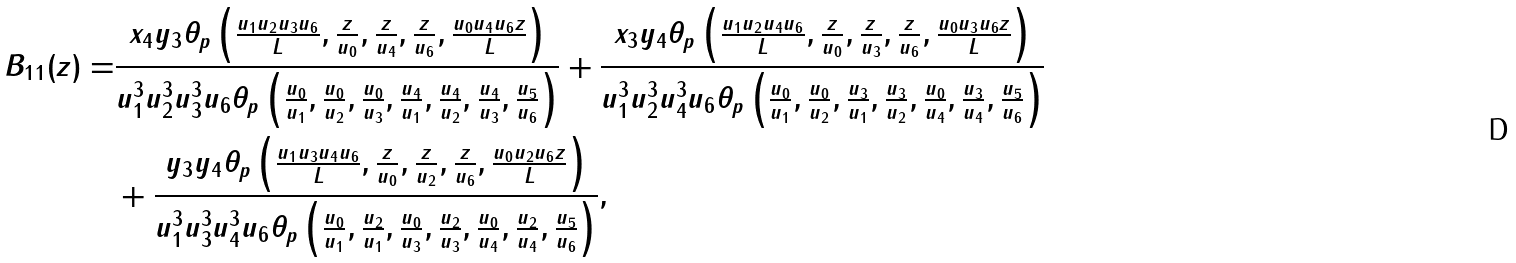Convert formula to latex. <formula><loc_0><loc_0><loc_500><loc_500>B _ { 1 1 } ( z ) = & \frac { x _ { 4 } y _ { 3 } \theta _ { p } \left ( \frac { u _ { 1 } u _ { 2 } u _ { 3 } u _ { 6 } } { L } , \frac { z } { u _ { 0 } } , \frac { z } { u _ { 4 } } , \frac { z } { u _ { 6 } } , \frac { u _ { 0 } u _ { 4 } u _ { 6 } z } { L } \right ) } { u _ { 1 } ^ { 3 } u _ { 2 } ^ { 3 } u _ { 3 } ^ { 3 } u _ { 6 } \theta _ { p } \left ( \frac { u _ { 0 } } { u _ { 1 } } , \frac { u _ { 0 } } { u _ { 2 } } , \frac { u _ { 0 } } { u _ { 3 } } , \frac { u _ { 4 } } { u _ { 1 } } , \frac { u _ { 4 } } { u _ { 2 } } , \frac { u _ { 4 } } { u _ { 3 } } , \frac { u _ { 5 } } { u _ { 6 } } \right ) } + \frac { x _ { 3 } y _ { 4 } \theta _ { p } \left ( \frac { u _ { 1 } u _ { 2 } u _ { 4 } u _ { 6 } } { L } , \frac { z } { u _ { 0 } } , \frac { z } { u _ { 3 } } , \frac { z } { u _ { 6 } } , \frac { u _ { 0 } u _ { 3 } u _ { 6 } z } { L } \right ) } { u _ { 1 } ^ { 3 } u _ { 2 } ^ { 3 } u _ { 4 } ^ { 3 } u _ { 6 } \theta _ { p } \left ( \frac { u _ { 0 } } { u _ { 1 } } , \frac { u _ { 0 } } { u _ { 2 } } , \frac { u _ { 3 } } { u _ { 1 } } , \frac { u _ { 3 } } { u _ { 2 } } , \frac { u _ { 0 } } { u _ { 4 } } , \frac { u _ { 3 } } { u _ { 4 } } , \frac { u _ { 5 } } { u _ { 6 } } \right ) } \\ & + \frac { y _ { 3 } y _ { 4 } \theta _ { p } \left ( \frac { u _ { 1 } u _ { 3 } u _ { 4 } u _ { 6 } } { L } , \frac { z } { u _ { 0 } } , \frac { z } { u _ { 2 } } , \frac { z } { u _ { 6 } } , \frac { u _ { 0 } u _ { 2 } u _ { 6 } z } { L } \right ) } { u _ { 1 } ^ { 3 } u _ { 3 } ^ { 3 } u _ { 4 } ^ { 3 } u _ { 6 } \theta _ { p } \left ( \frac { u _ { 0 } } { u _ { 1 } } , \frac { u _ { 2 } } { u _ { 1 } } , \frac { u _ { 0 } } { u _ { 3 } } , \frac { u _ { 2 } } { u _ { 3 } } , \frac { u _ { 0 } } { u _ { 4 } } , \frac { u _ { 2 } } { u _ { 4 } } , \frac { u _ { 5 } } { u _ { 6 } } \right ) } ,</formula> 